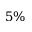Convert formula to latex. <formula><loc_0><loc_0><loc_500><loc_500>5 \%</formula> 